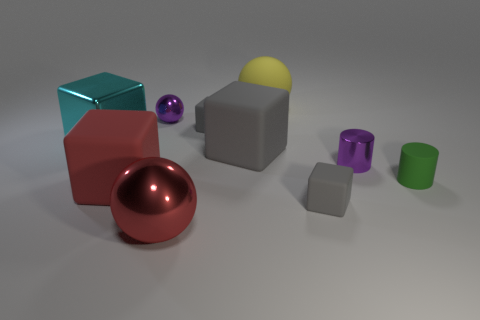Is there a metallic object that has the same shape as the large red rubber thing?
Make the answer very short. Yes. There is a small gray object in front of the small rubber cylinder; what shape is it?
Provide a short and direct response. Cube. How many big things have the same material as the big cyan cube?
Ensure brevity in your answer.  1. Is the number of gray rubber cubes left of the small purple metal sphere less than the number of small rubber cylinders?
Your answer should be compact. Yes. How big is the metal object in front of the tiny gray cube that is in front of the red matte thing?
Ensure brevity in your answer.  Large. Do the tiny metal cylinder and the small shiny sphere behind the red rubber block have the same color?
Your answer should be compact. Yes. There is a purple cylinder that is the same size as the green rubber thing; what is it made of?
Your answer should be compact. Metal. Are there fewer green objects behind the green rubber object than rubber cubes that are to the right of the large red matte thing?
Keep it short and to the point. Yes. What shape is the small gray thing that is in front of the rubber object that is left of the small purple metal sphere?
Ensure brevity in your answer.  Cube. Is there a tiny brown matte object?
Ensure brevity in your answer.  No. 